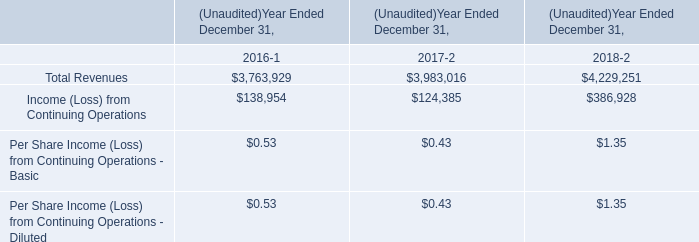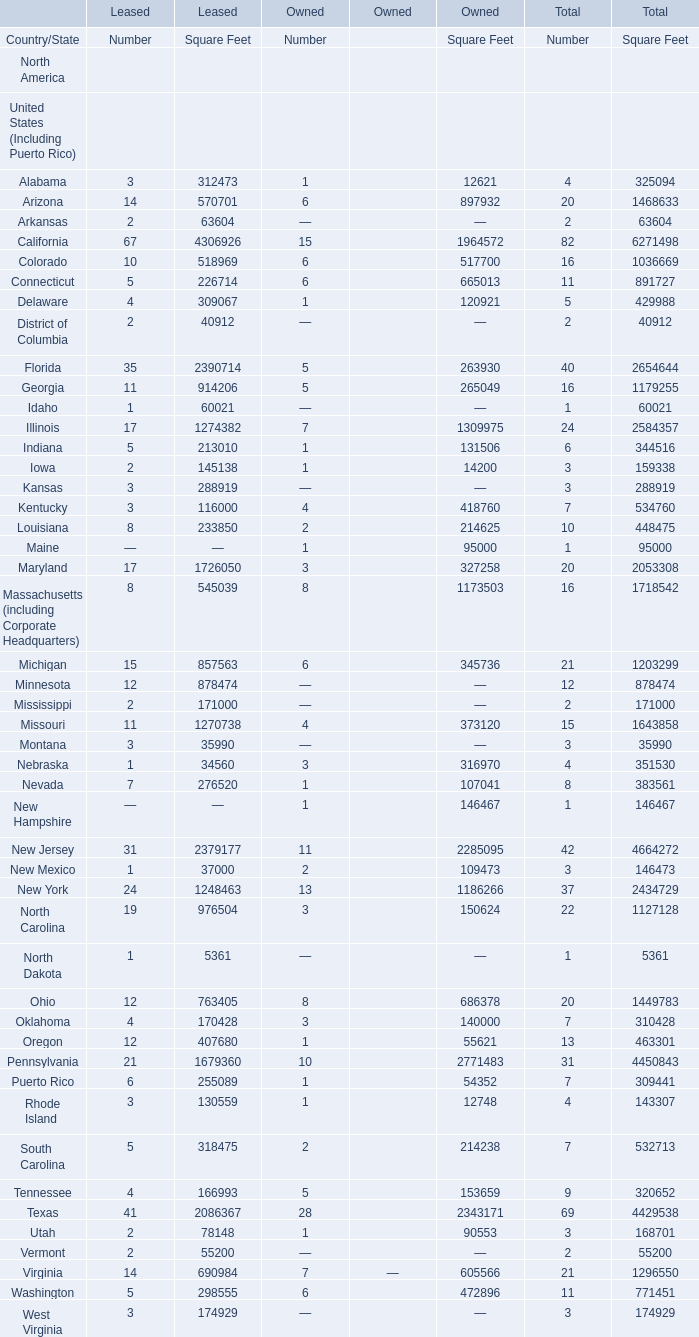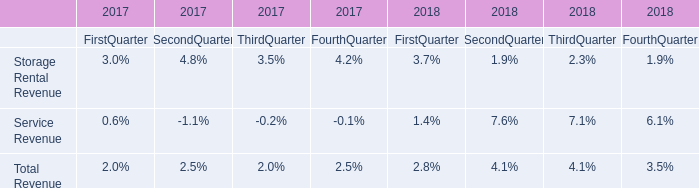What is the percentage of California in relation to the total for Square Feet of Total?? 
Computations: (6271498 / 56040880)
Answer: 0.11191. 